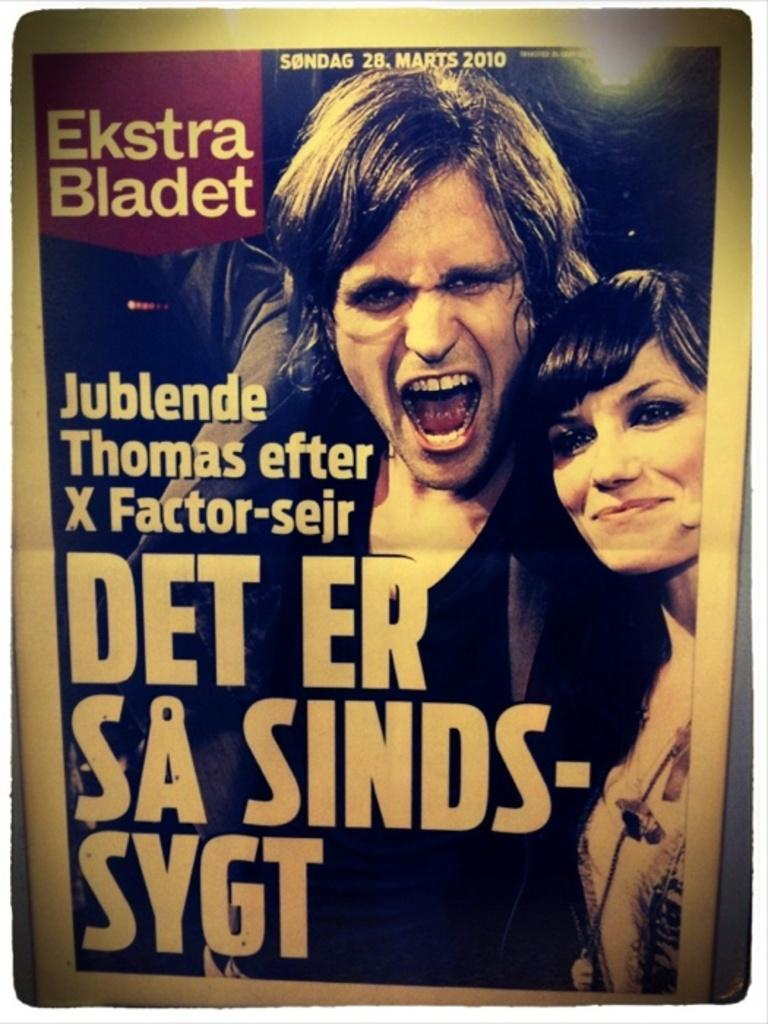What is featured in the picture? There is a poster in the picture. What can be seen on the poster? There are two persons and a woman on the poster. Where is the text located on the poster? The text is on the left side of the poster. How is the woman depicted on the poster? The woman is smiling on the right side of the poster. What type of marble is used to create the floor in the image? There is no mention of a floor or marble in the image; it features a poster with two persons and a woman. 